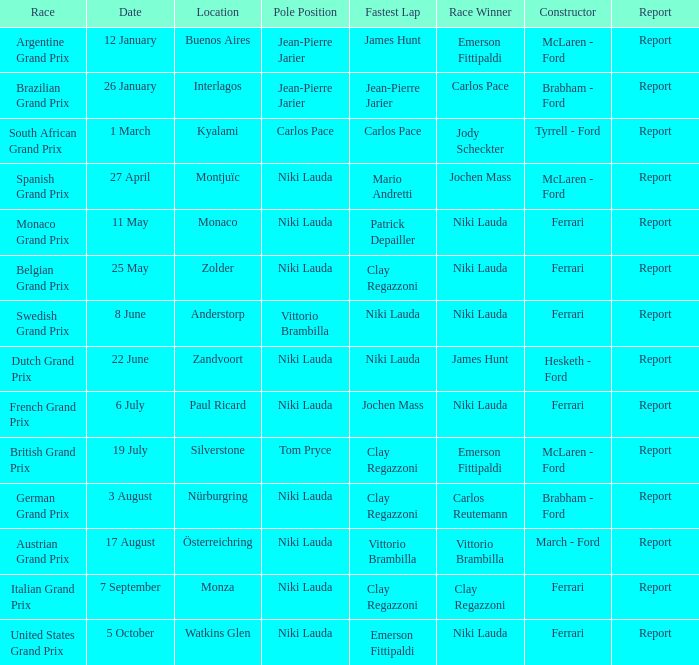Who completed the speediest lap in the team that took part in zolder, with ferrari as the constructor? Clay Regazzoni. 